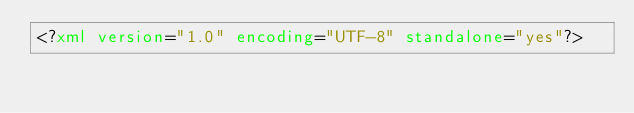Convert code to text. <code><loc_0><loc_0><loc_500><loc_500><_XML_><?xml version="1.0" encoding="UTF-8" standalone="yes"?></code> 